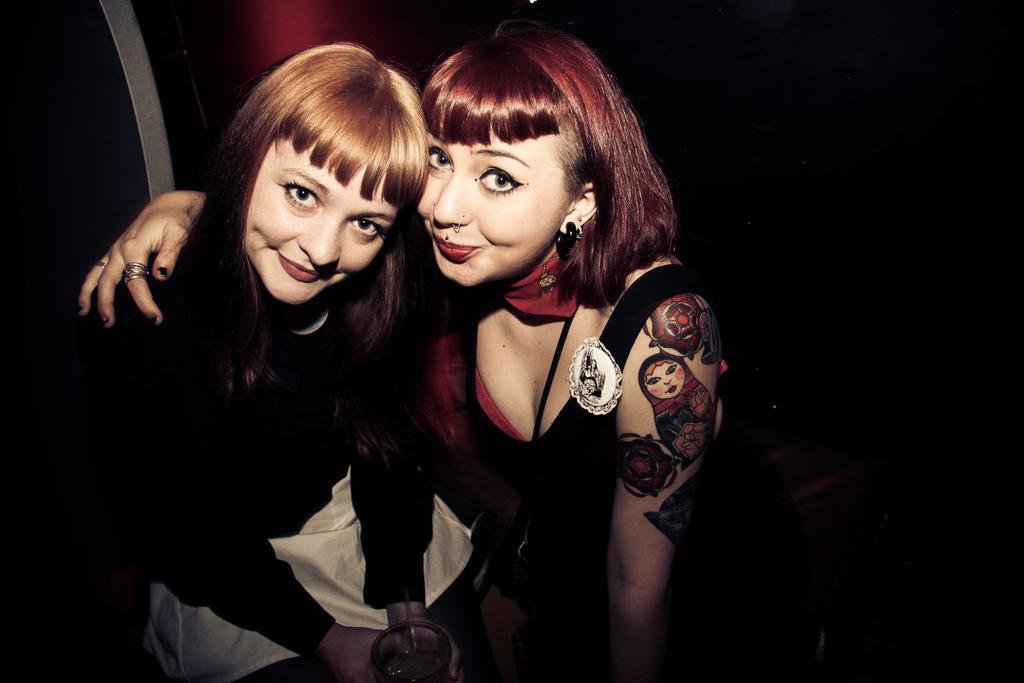Could you give a brief overview of what you see in this image? In this image we can see two girls sitting and one of the girls is holding a glass. The background is dark. 